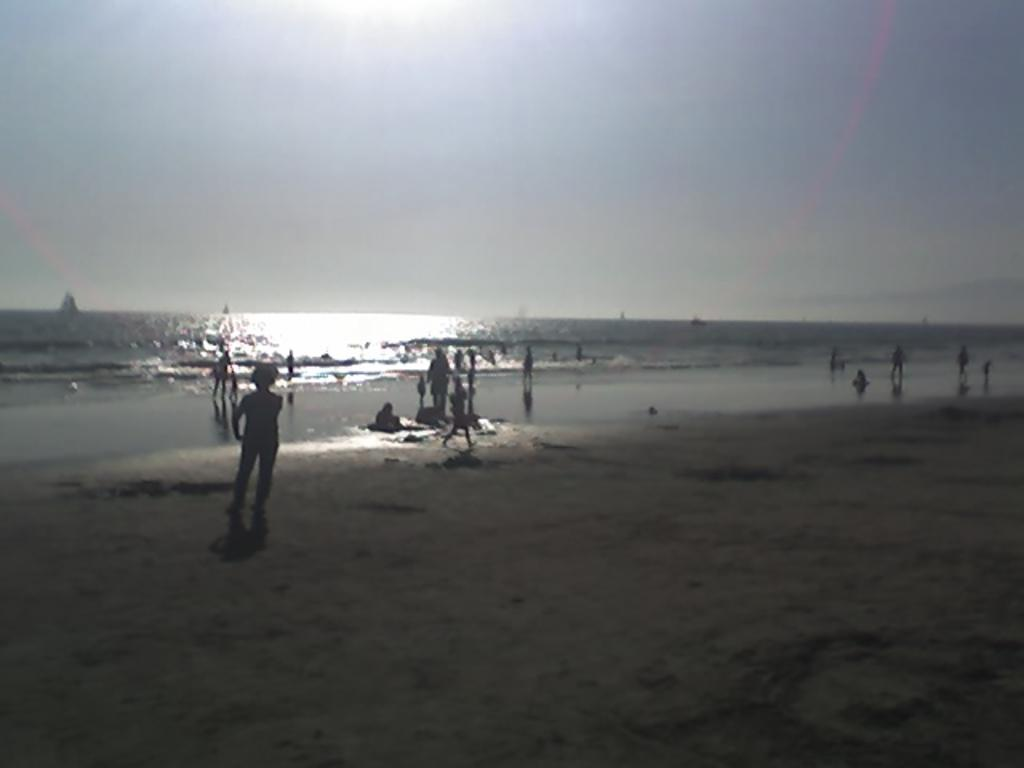What can be seen in the image? There are people standing in the image. What is at the bottom of the image? There is sand at the bottom of the image. What else is visible in the image besides the people and sand? There is water visible in the image. What is visible at the top of the image? The sky is visible at the top of the image. Where is the book located in the image? There is no book present in the image. What type of bead can be seen in the image? There are no beads present in the image. 